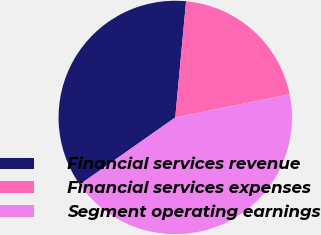Convert chart to OTSL. <chart><loc_0><loc_0><loc_500><loc_500><pie_chart><fcel>Financial services revenue<fcel>Financial services expenses<fcel>Segment operating earnings<nl><fcel>36.21%<fcel>20.34%<fcel>43.45%<nl></chart> 